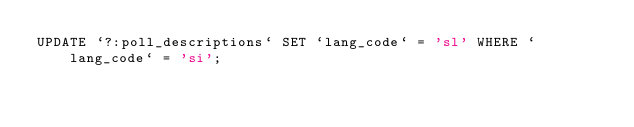Convert code to text. <code><loc_0><loc_0><loc_500><loc_500><_SQL_>UPDATE `?:poll_descriptions` SET `lang_code` = 'sl' WHERE `lang_code` = 'si';
</code> 